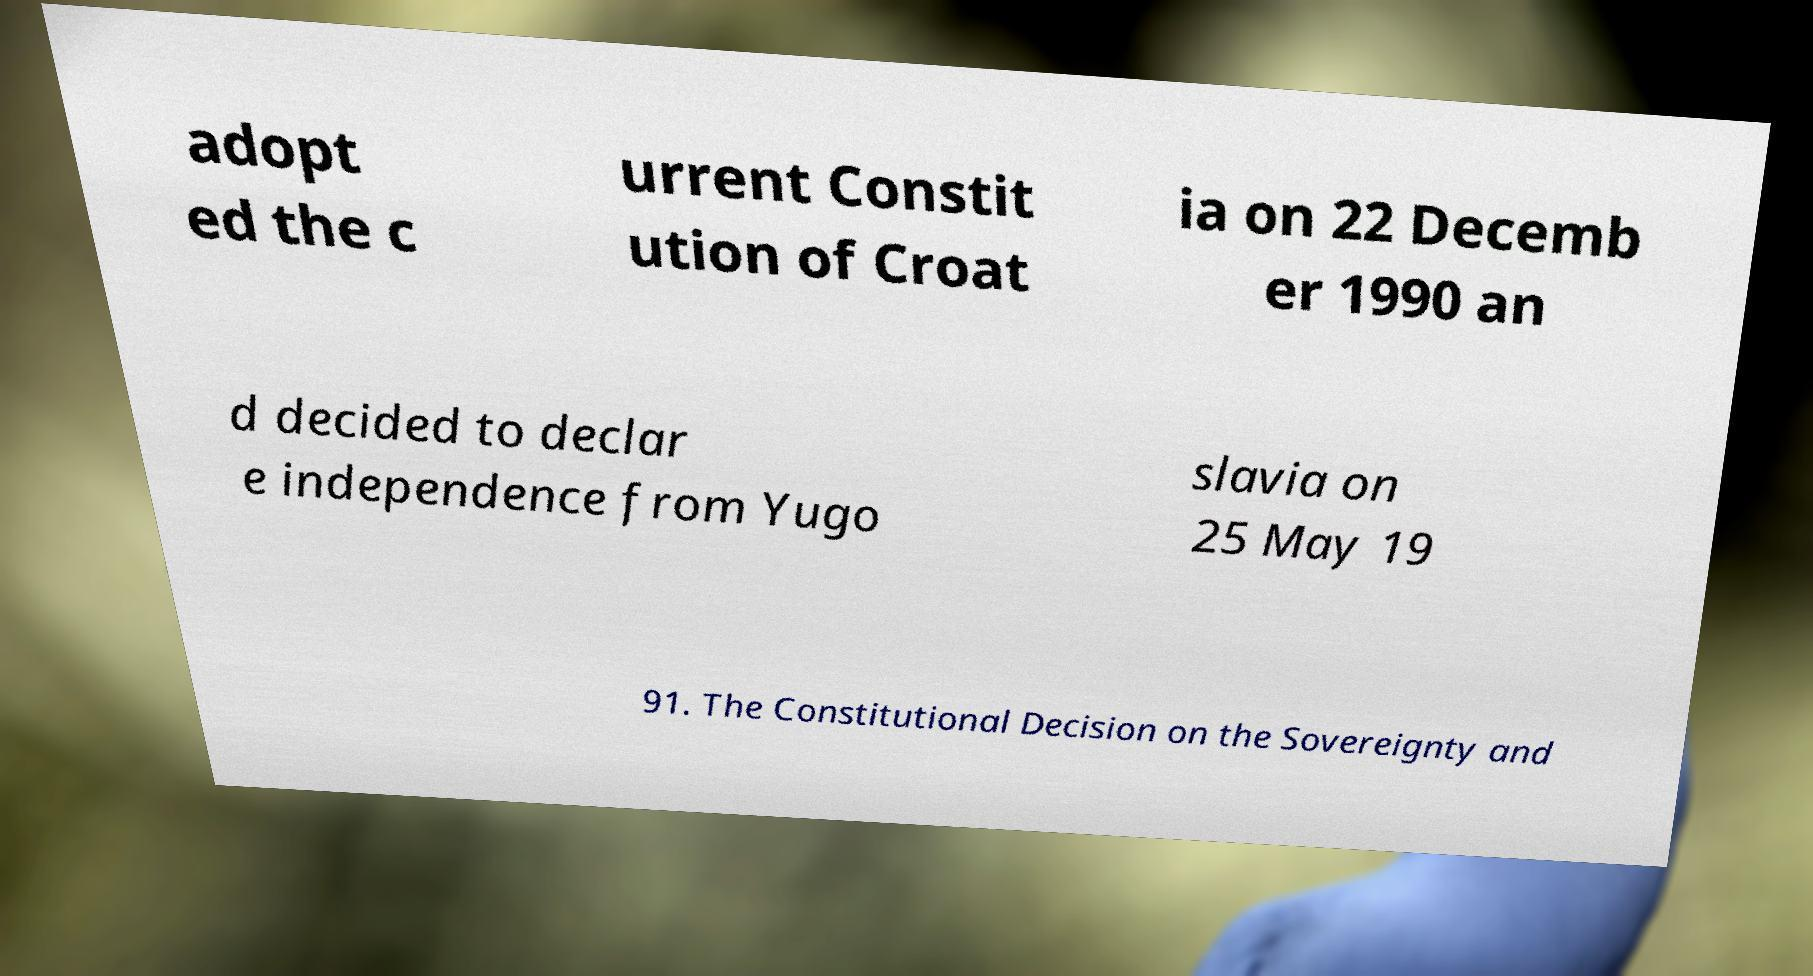Can you accurately transcribe the text from the provided image for me? adopt ed the c urrent Constit ution of Croat ia on 22 Decemb er 1990 an d decided to declar e independence from Yugo slavia on 25 May 19 91. The Constitutional Decision on the Sovereignty and 